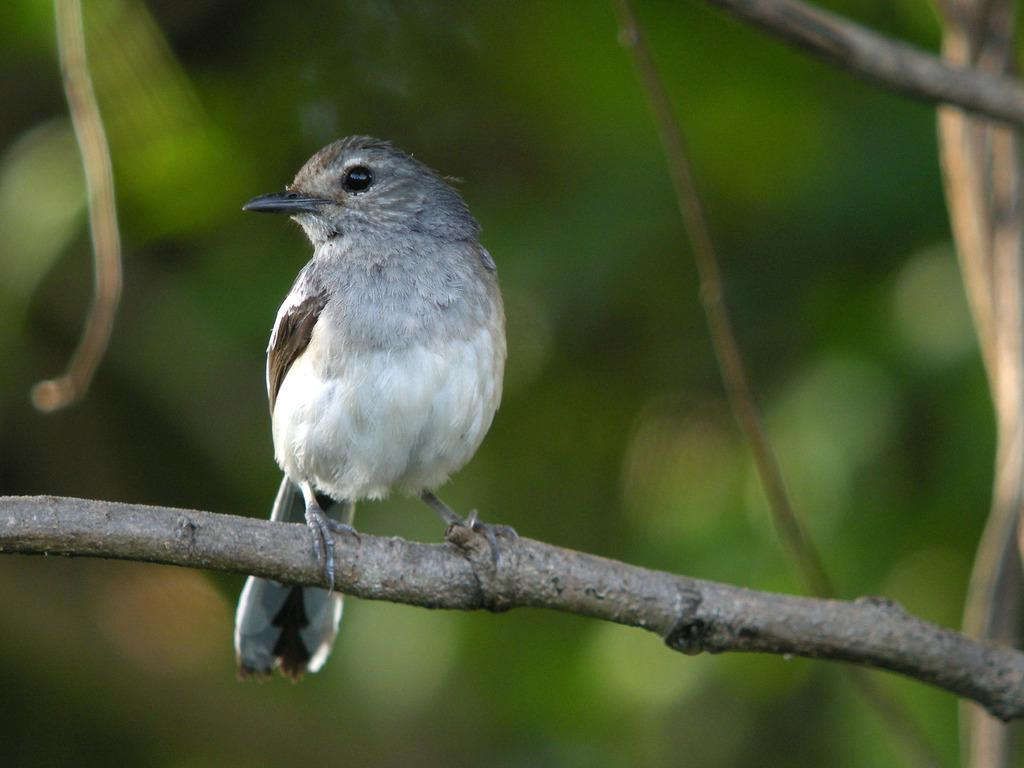What is the main subject of the image? There is a bird on a stem in the image. Which direction is the bird looking? The bird is looking to the left side. What can be seen on the right side of the image? There are stems visible on the right side of the image. How would you describe the background of the image? The background of the image is blurred. What type of instrument is the bird playing in the image? There is no instrument present in the image, and the bird is not playing any instrument. 